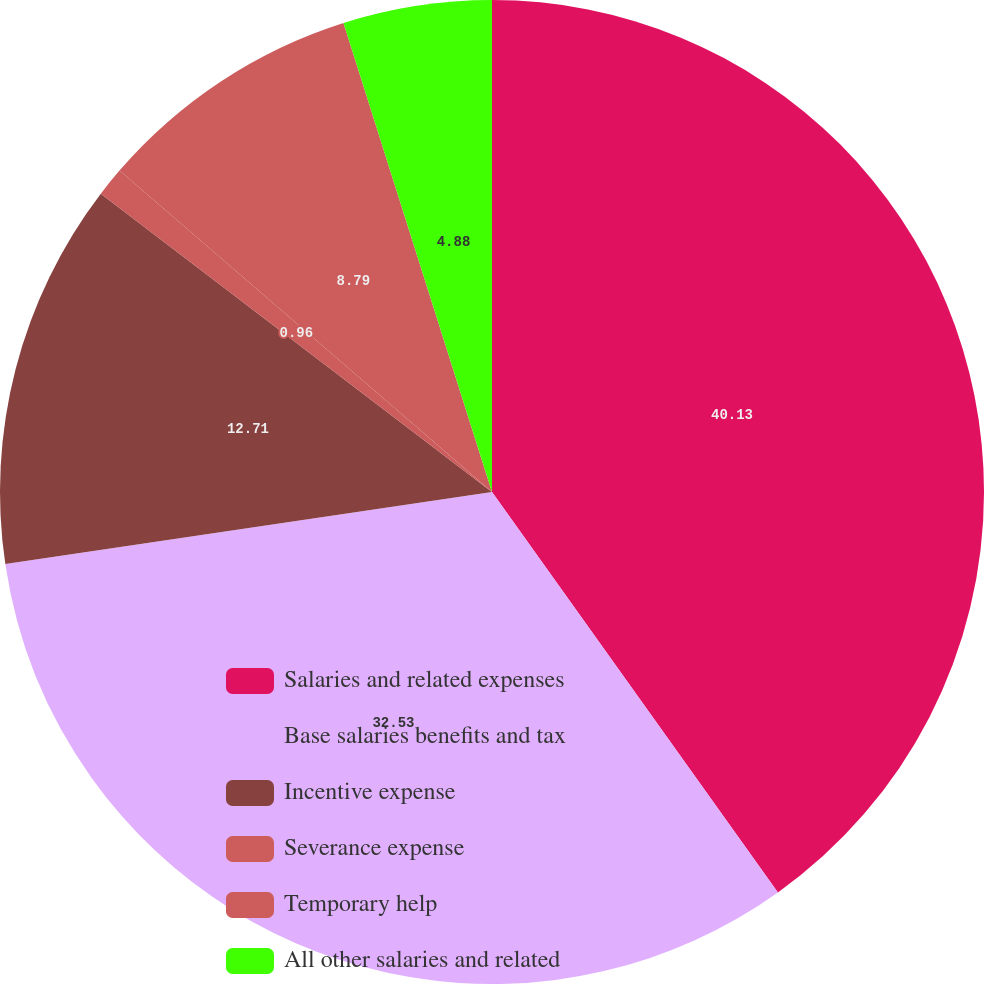Convert chart to OTSL. <chart><loc_0><loc_0><loc_500><loc_500><pie_chart><fcel>Salaries and related expenses<fcel>Base salaries benefits and tax<fcel>Incentive expense<fcel>Severance expense<fcel>Temporary help<fcel>All other salaries and related<nl><fcel>40.13%<fcel>32.53%<fcel>12.71%<fcel>0.96%<fcel>8.79%<fcel>4.88%<nl></chart> 